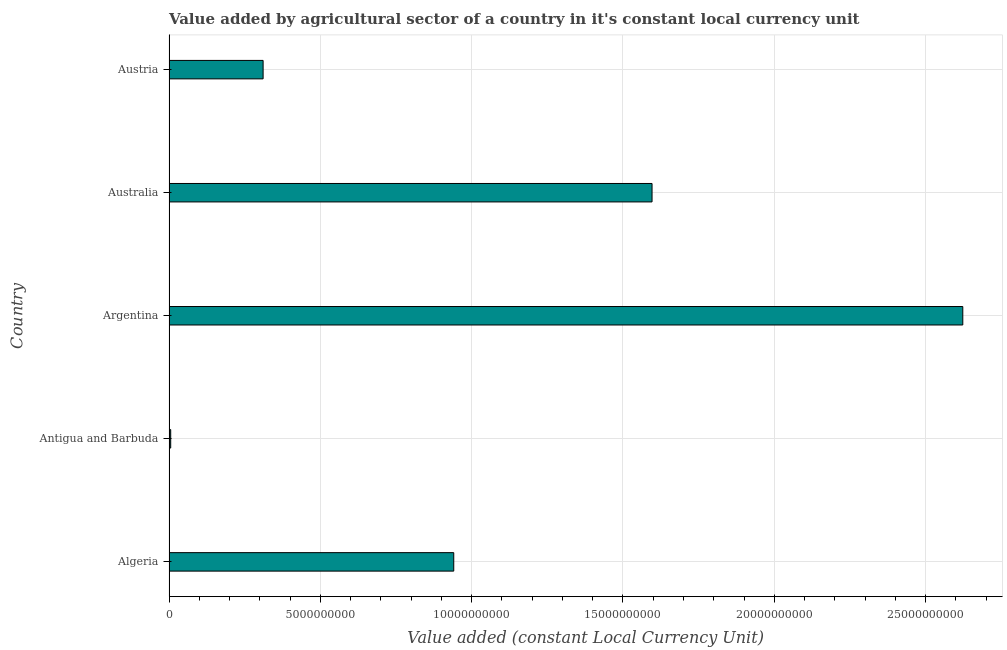What is the title of the graph?
Your answer should be very brief. Value added by agricultural sector of a country in it's constant local currency unit. What is the label or title of the X-axis?
Your answer should be very brief. Value added (constant Local Currency Unit). What is the label or title of the Y-axis?
Give a very brief answer. Country. What is the value added by agriculture sector in Austria?
Ensure brevity in your answer.  3.11e+09. Across all countries, what is the maximum value added by agriculture sector?
Ensure brevity in your answer.  2.62e+1. Across all countries, what is the minimum value added by agriculture sector?
Your answer should be compact. 5.61e+07. In which country was the value added by agriculture sector minimum?
Provide a short and direct response. Antigua and Barbuda. What is the sum of the value added by agriculture sector?
Make the answer very short. 5.48e+1. What is the difference between the value added by agriculture sector in Antigua and Barbuda and Argentina?
Make the answer very short. -2.62e+1. What is the average value added by agriculture sector per country?
Your answer should be very brief. 1.10e+1. What is the median value added by agriculture sector?
Your answer should be compact. 9.41e+09. What is the ratio of the value added by agriculture sector in Antigua and Barbuda to that in Australia?
Offer a terse response. 0. Is the value added by agriculture sector in Antigua and Barbuda less than that in Australia?
Give a very brief answer. Yes. What is the difference between the highest and the second highest value added by agriculture sector?
Ensure brevity in your answer.  1.03e+1. Is the sum of the value added by agriculture sector in Argentina and Australia greater than the maximum value added by agriculture sector across all countries?
Your answer should be very brief. Yes. What is the difference between the highest and the lowest value added by agriculture sector?
Offer a terse response. 2.62e+1. In how many countries, is the value added by agriculture sector greater than the average value added by agriculture sector taken over all countries?
Your response must be concise. 2. How many bars are there?
Your response must be concise. 5. Are the values on the major ticks of X-axis written in scientific E-notation?
Your response must be concise. No. What is the Value added (constant Local Currency Unit) of Algeria?
Your response must be concise. 9.41e+09. What is the Value added (constant Local Currency Unit) in Antigua and Barbuda?
Your answer should be compact. 5.61e+07. What is the Value added (constant Local Currency Unit) of Argentina?
Your response must be concise. 2.62e+1. What is the Value added (constant Local Currency Unit) of Australia?
Provide a succinct answer. 1.60e+1. What is the Value added (constant Local Currency Unit) in Austria?
Your answer should be compact. 3.11e+09. What is the difference between the Value added (constant Local Currency Unit) in Algeria and Antigua and Barbuda?
Make the answer very short. 9.35e+09. What is the difference between the Value added (constant Local Currency Unit) in Algeria and Argentina?
Keep it short and to the point. -1.68e+1. What is the difference between the Value added (constant Local Currency Unit) in Algeria and Australia?
Offer a terse response. -6.55e+09. What is the difference between the Value added (constant Local Currency Unit) in Algeria and Austria?
Give a very brief answer. 6.30e+09. What is the difference between the Value added (constant Local Currency Unit) in Antigua and Barbuda and Argentina?
Keep it short and to the point. -2.62e+1. What is the difference between the Value added (constant Local Currency Unit) in Antigua and Barbuda and Australia?
Ensure brevity in your answer.  -1.59e+1. What is the difference between the Value added (constant Local Currency Unit) in Antigua and Barbuda and Austria?
Your answer should be very brief. -3.05e+09. What is the difference between the Value added (constant Local Currency Unit) in Argentina and Australia?
Give a very brief answer. 1.03e+1. What is the difference between the Value added (constant Local Currency Unit) in Argentina and Austria?
Provide a short and direct response. 2.31e+1. What is the difference between the Value added (constant Local Currency Unit) in Australia and Austria?
Keep it short and to the point. 1.29e+1. What is the ratio of the Value added (constant Local Currency Unit) in Algeria to that in Antigua and Barbuda?
Ensure brevity in your answer.  167.75. What is the ratio of the Value added (constant Local Currency Unit) in Algeria to that in Argentina?
Provide a short and direct response. 0.36. What is the ratio of the Value added (constant Local Currency Unit) in Algeria to that in Australia?
Offer a very short reply. 0.59. What is the ratio of the Value added (constant Local Currency Unit) in Algeria to that in Austria?
Offer a very short reply. 3.03. What is the ratio of the Value added (constant Local Currency Unit) in Antigua and Barbuda to that in Argentina?
Offer a very short reply. 0. What is the ratio of the Value added (constant Local Currency Unit) in Antigua and Barbuda to that in Australia?
Your response must be concise. 0. What is the ratio of the Value added (constant Local Currency Unit) in Antigua and Barbuda to that in Austria?
Offer a very short reply. 0.02. What is the ratio of the Value added (constant Local Currency Unit) in Argentina to that in Australia?
Offer a terse response. 1.64. What is the ratio of the Value added (constant Local Currency Unit) in Argentina to that in Austria?
Offer a very short reply. 8.44. What is the ratio of the Value added (constant Local Currency Unit) in Australia to that in Austria?
Offer a terse response. 5.13. 